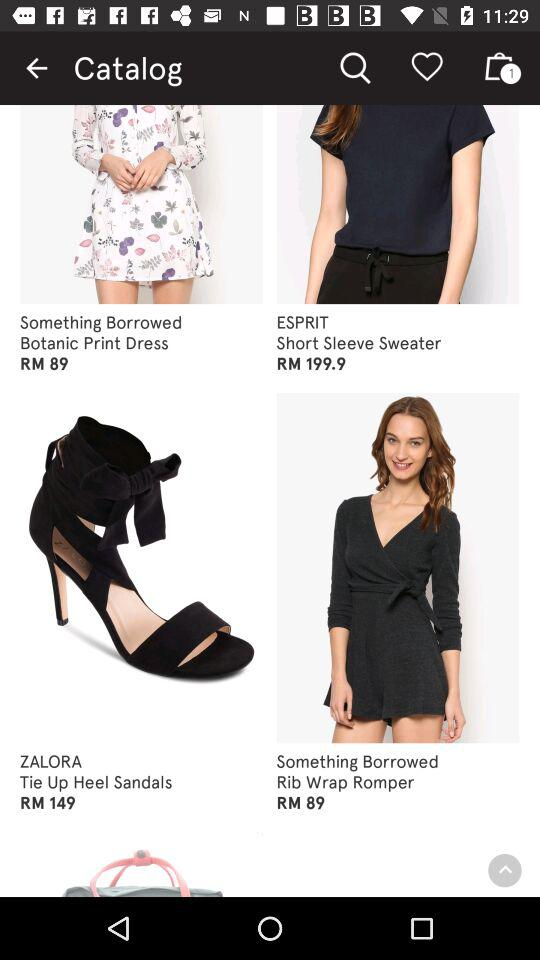What is the price of the Rib Wrap Romper? The price is RM89. 